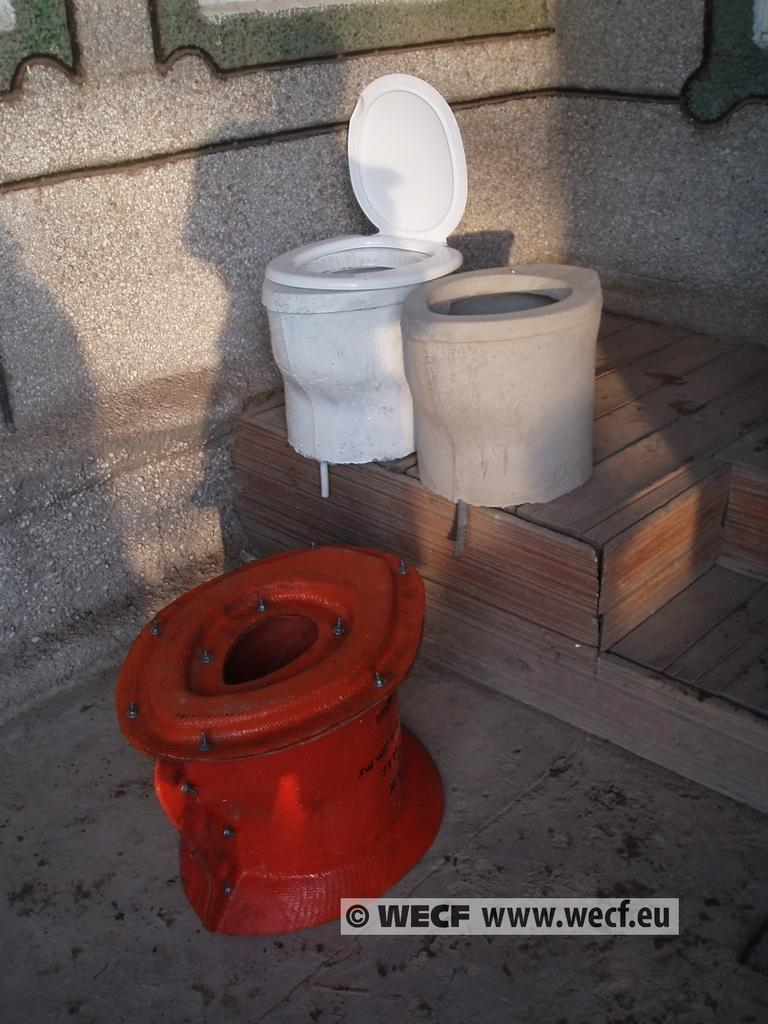<image>
Summarize the visual content of the image. Three outdoor toilets with the website www.wecf.eu listed underneath them. 